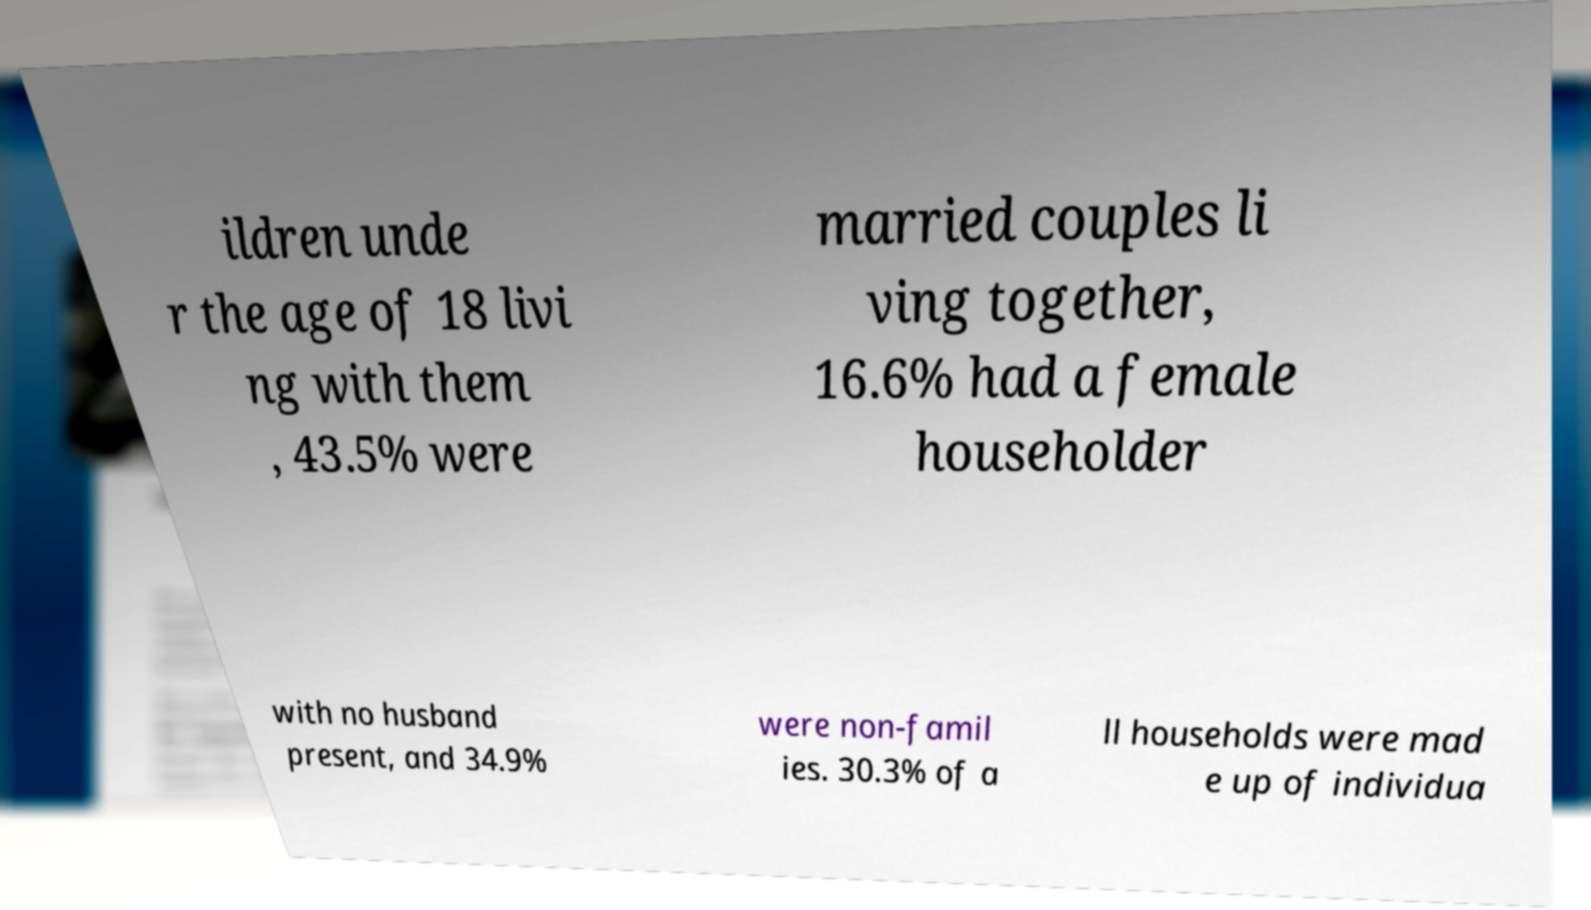What messages or text are displayed in this image? I need them in a readable, typed format. ildren unde r the age of 18 livi ng with them , 43.5% were married couples li ving together, 16.6% had a female householder with no husband present, and 34.9% were non-famil ies. 30.3% of a ll households were mad e up of individua 